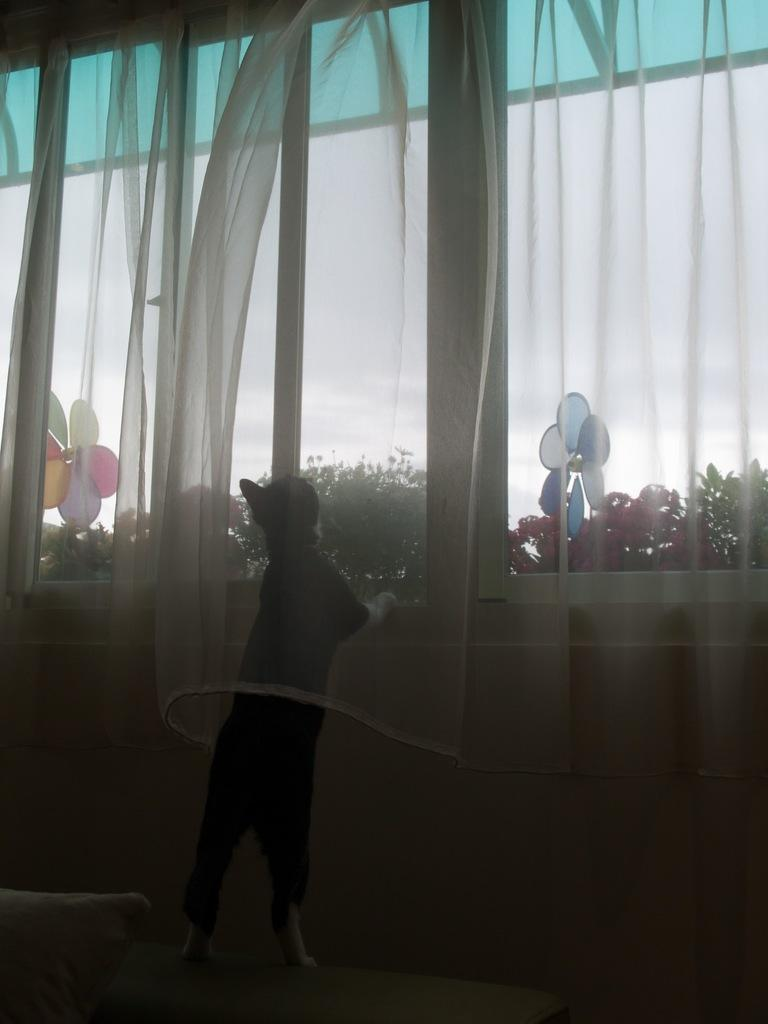What is the main subject in the image? There is a person standing in the image. What can be seen hanging in the image? There are curtains hanging in the image. What type of vegetation is visible in the background of the image? There are trees visible in the background of the image. What part of the natural environment can be seen through the windows in the background of the image? The sky is visible through the glass windows in the background of the image. Can you tell me how many shoes are visible in the image? There are no shoes visible in the image. What type of window is being touched by the person in the image? There is no indication that the person is touching a window in the image. 